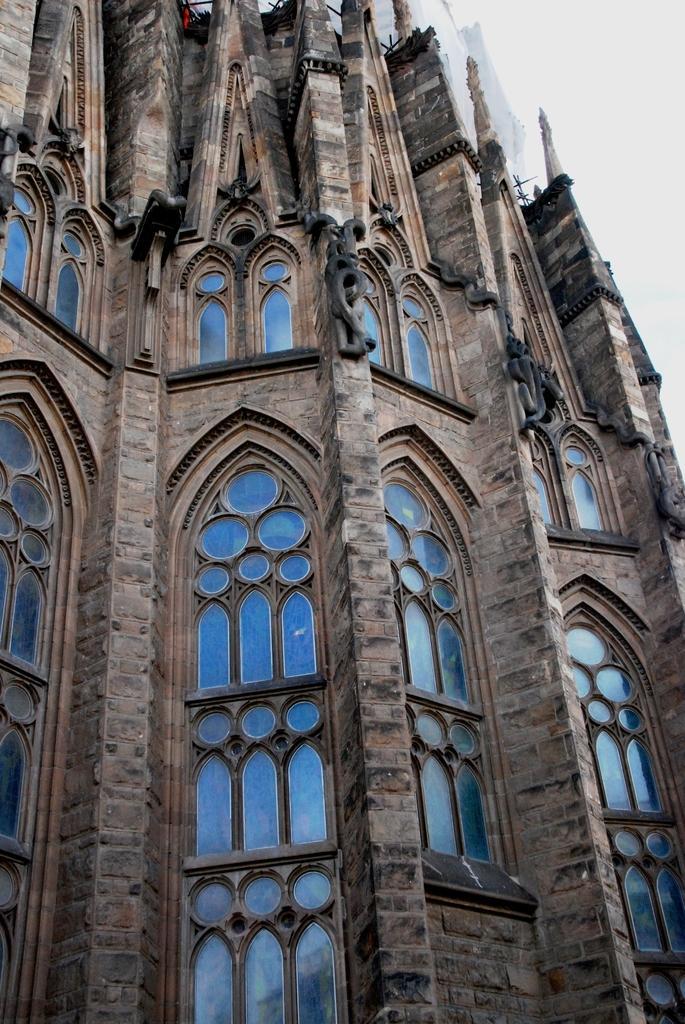Describe this image in one or two sentences. In the center of the image there is a building. In the background there is sky. 